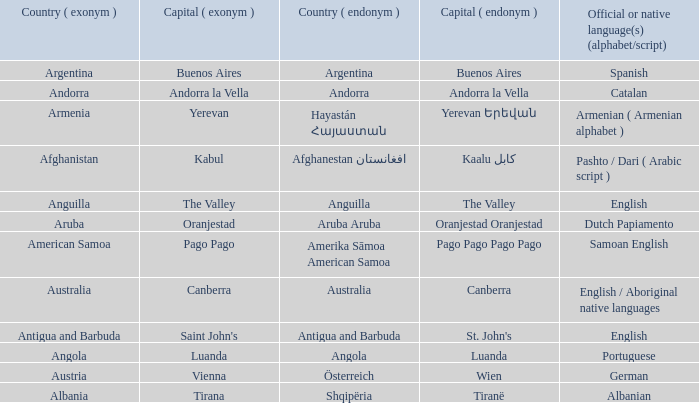What is the local name given to the city of Canberra? Canberra. 